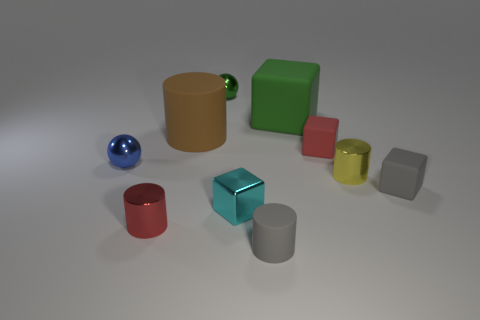How many things are large yellow blocks or cyan blocks?
Offer a very short reply. 1. What number of other things are there of the same color as the tiny matte cylinder?
Offer a very short reply. 1. The yellow metal thing that is the same size as the gray cylinder is what shape?
Ensure brevity in your answer.  Cylinder. There is a big matte thing right of the cyan object; what color is it?
Offer a terse response. Green. What number of objects are either matte cylinders on the left side of the gray cylinder or matte things that are left of the cyan metallic object?
Provide a succinct answer. 1. Is the size of the green rubber cube the same as the yellow cylinder?
Give a very brief answer. No. How many spheres are cyan objects or gray rubber objects?
Your answer should be very brief. 0. How many matte cylinders are behind the small red metallic thing and on the right side of the shiny block?
Keep it short and to the point. 0. Do the blue thing and the red thing that is left of the red rubber thing have the same size?
Give a very brief answer. Yes. There is a sphere that is left of the ball behind the small blue metallic object; are there any red things that are on the left side of it?
Ensure brevity in your answer.  No. 